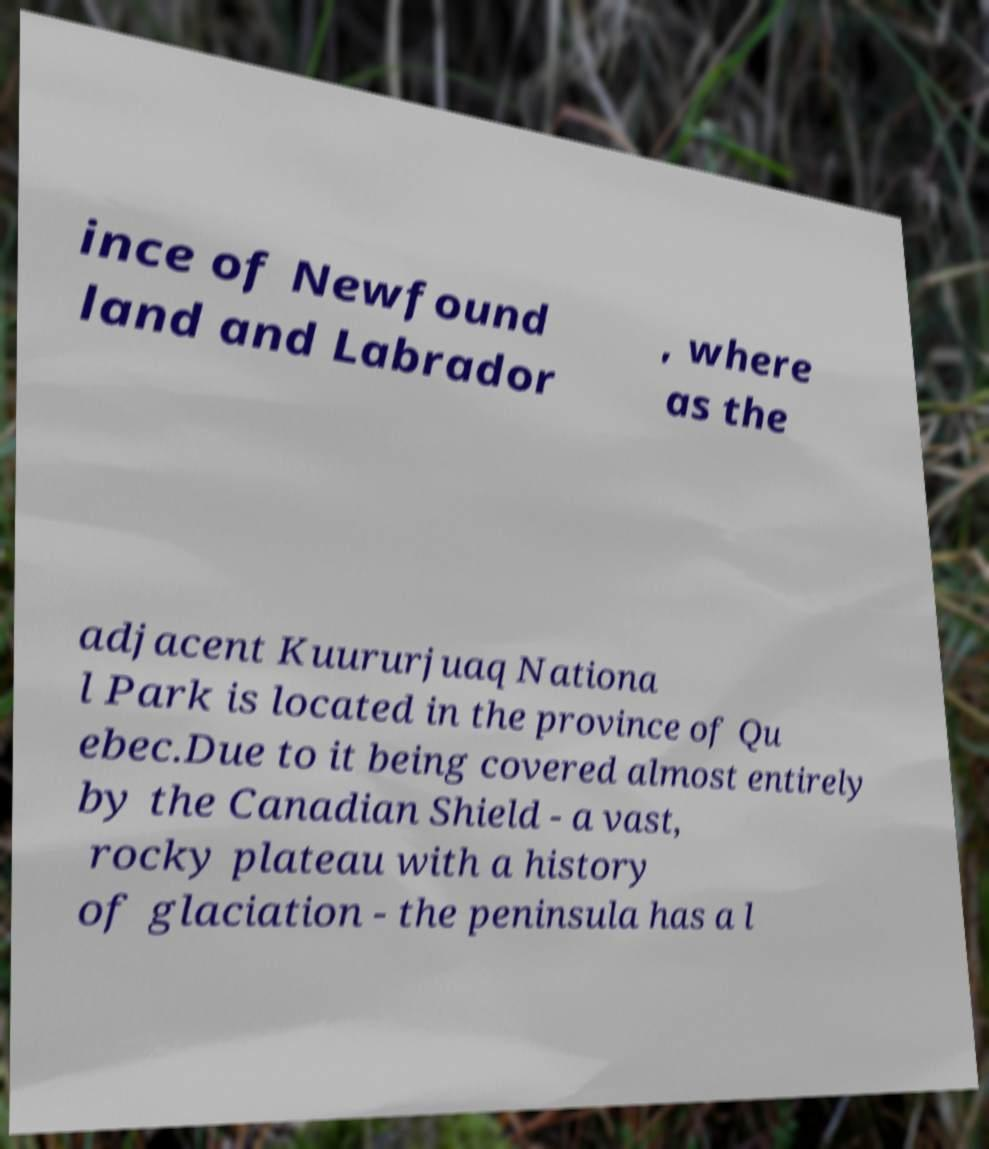What messages or text are displayed in this image? I need them in a readable, typed format. ince of Newfound land and Labrador , where as the adjacent Kuururjuaq Nationa l Park is located in the province of Qu ebec.Due to it being covered almost entirely by the Canadian Shield - a vast, rocky plateau with a history of glaciation - the peninsula has a l 